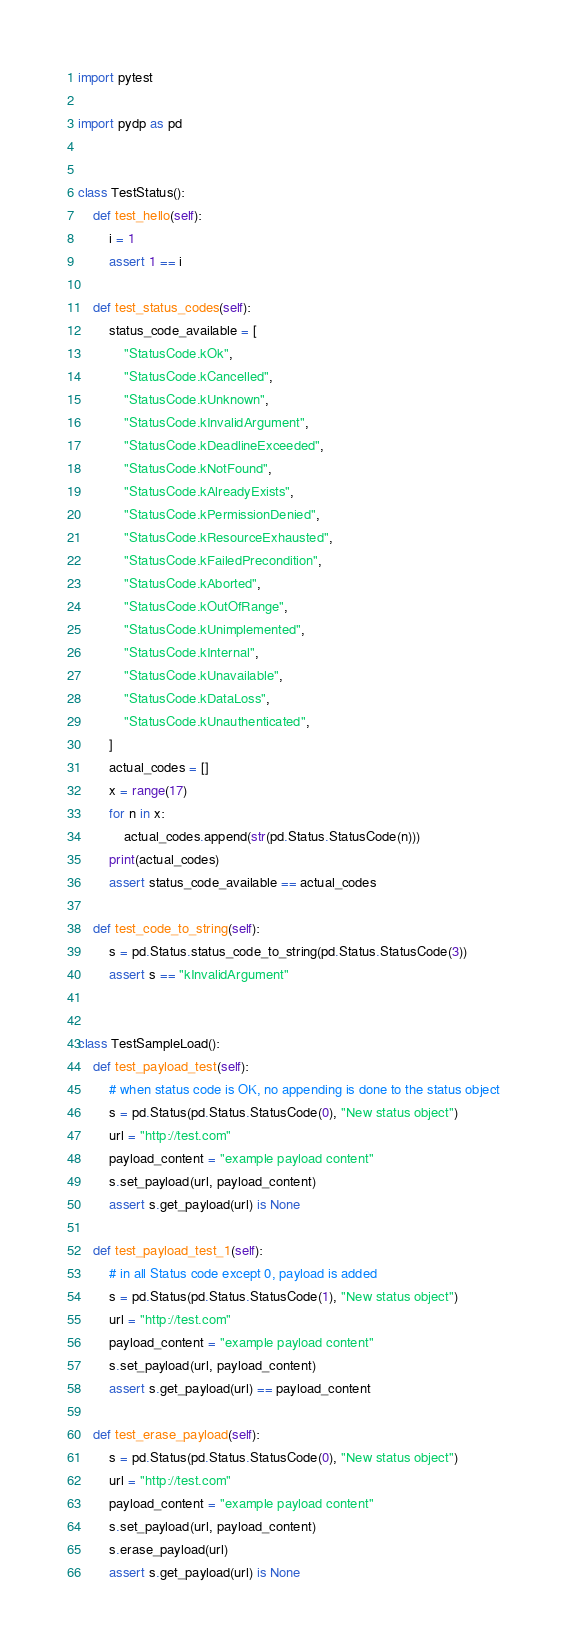Convert code to text. <code><loc_0><loc_0><loc_500><loc_500><_Python_>import pytest

import pydp as pd


class TestStatus():
    def test_hello(self):
        i = 1
        assert 1 == i

    def test_status_codes(self):
        status_code_available = [
            "StatusCode.kOk",
            "StatusCode.kCancelled",
            "StatusCode.kUnknown",
            "StatusCode.kInvalidArgument",
            "StatusCode.kDeadlineExceeded",
            "StatusCode.kNotFound",
            "StatusCode.kAlreadyExists",
            "StatusCode.kPermissionDenied",
            "StatusCode.kResourceExhausted",
            "StatusCode.kFailedPrecondition",
            "StatusCode.kAborted",
            "StatusCode.kOutOfRange",
            "StatusCode.kUnimplemented",
            "StatusCode.kInternal",
            "StatusCode.kUnavailable",
            "StatusCode.kDataLoss",
            "StatusCode.kUnauthenticated",
        ]
        actual_codes = []
        x = range(17)
        for n in x:
            actual_codes.append(str(pd.Status.StatusCode(n)))
        print(actual_codes)
        assert status_code_available == actual_codes

    def test_code_to_string(self):
        s = pd.Status.status_code_to_string(pd.Status.StatusCode(3))
        assert s == "kInvalidArgument"


class TestSampleLoad():
    def test_payload_test(self):
        # when status code is OK, no appending is done to the status object
        s = pd.Status(pd.Status.StatusCode(0), "New status object")
        url = "http://test.com"
        payload_content = "example payload content"
        s.set_payload(url, payload_content)
        assert s.get_payload(url) is None

    def test_payload_test_1(self):
        # in all Status code except 0, payload is added
        s = pd.Status(pd.Status.StatusCode(1), "New status object")
        url = "http://test.com"
        payload_content = "example payload content"
        s.set_payload(url, payload_content)
        assert s.get_payload(url) == payload_content

    def test_erase_payload(self):
        s = pd.Status(pd.Status.StatusCode(0), "New status object")
        url = "http://test.com"
        payload_content = "example payload content"
        s.set_payload(url, payload_content)
        s.erase_payload(url)
        assert s.get_payload(url) is None
</code> 